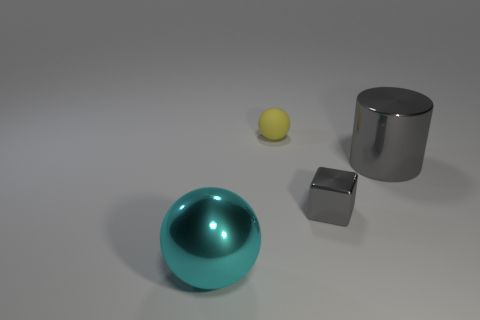Add 2 rubber spheres. How many objects exist? 6 Subtract all cylinders. How many objects are left? 3 Add 2 metal objects. How many metal objects exist? 5 Subtract 0 green blocks. How many objects are left? 4 Subtract all big brown rubber cylinders. Subtract all metal objects. How many objects are left? 1 Add 4 metallic blocks. How many metallic blocks are left? 5 